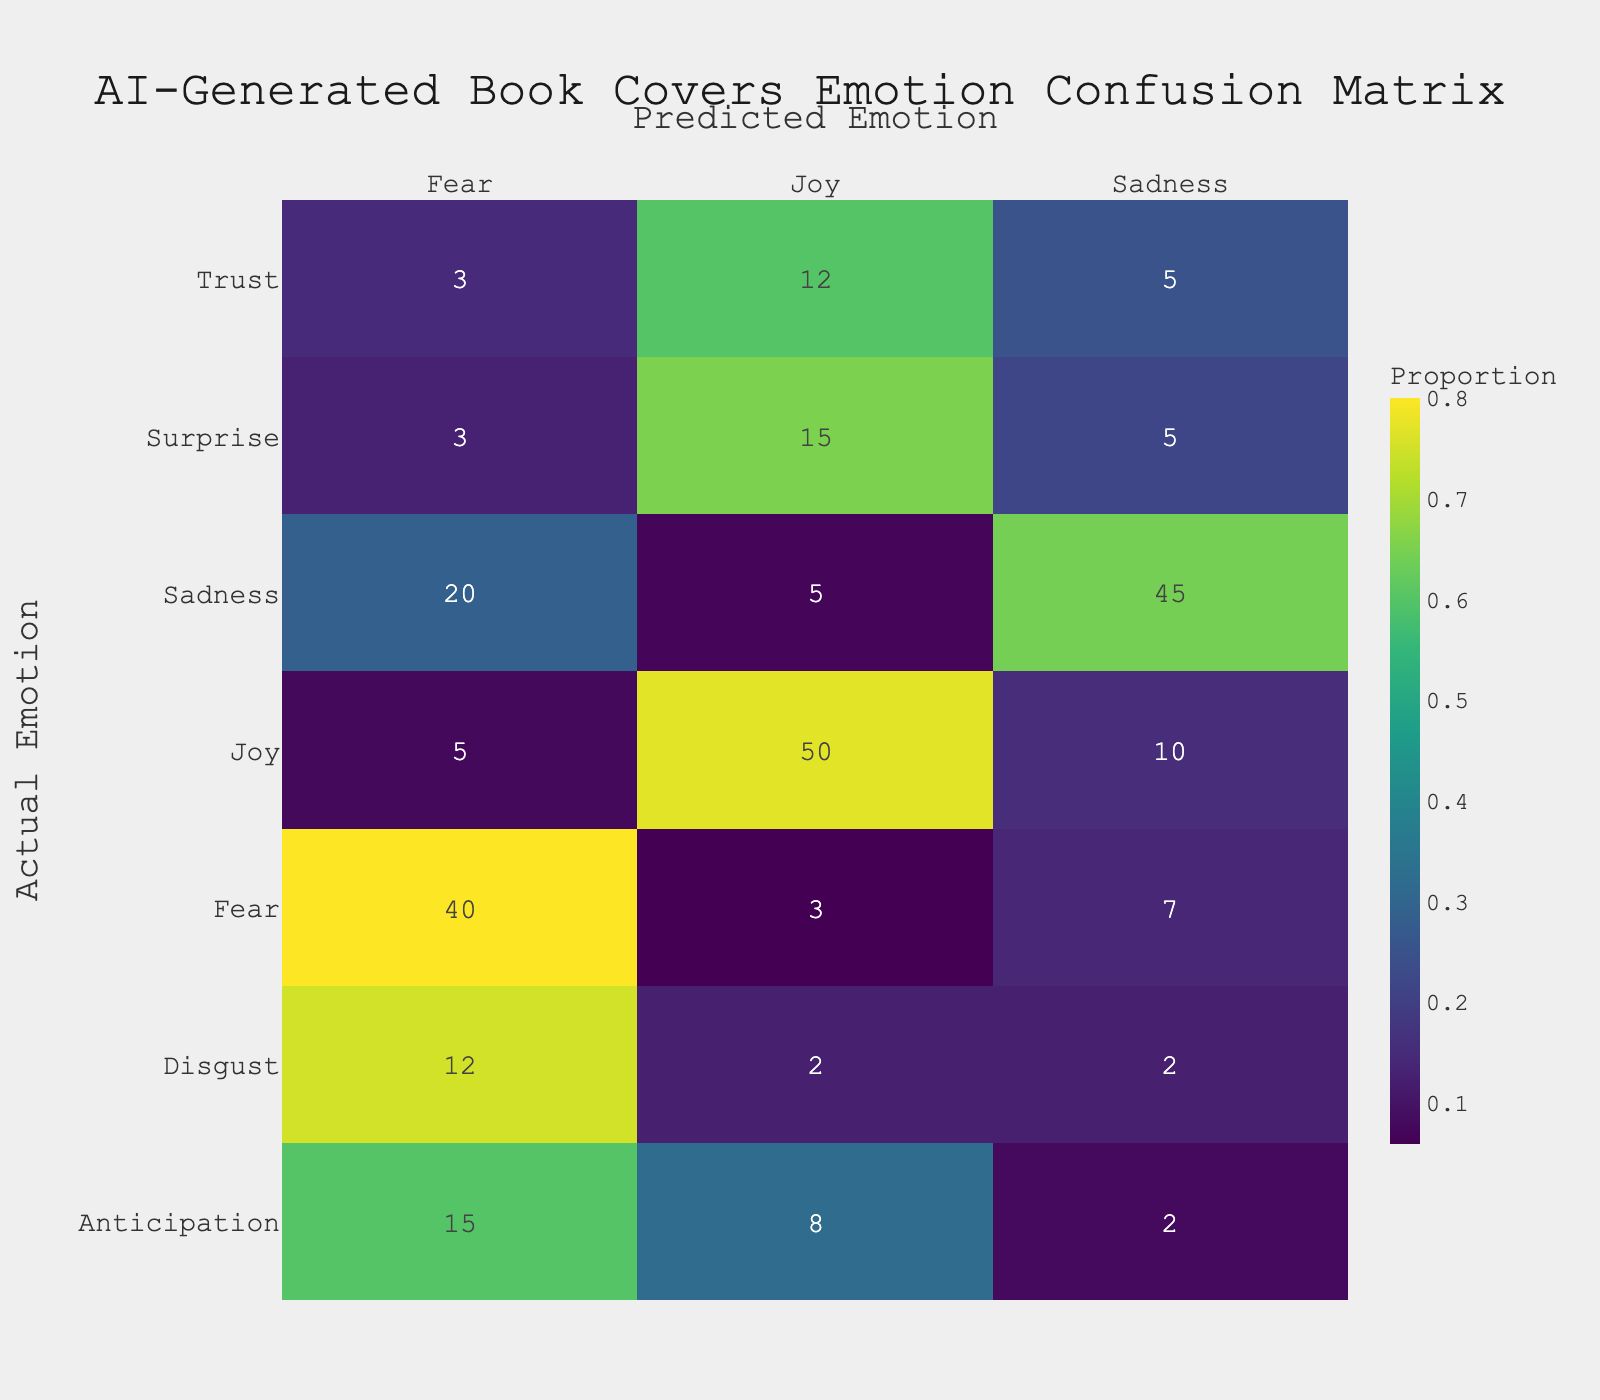What is the count of Joy predicted when the actual emotion is Joy? The table shows that when the actual emotion is Joy, the predicted emotion is also Joy with a count of 50.
Answer: 50 What is the total count of predicted emotions for the actual emotion of Sadness? To find this, we sum the counts for all predicted emotions when actual emotion is Sadness: 5 (Joy) + 45 (Sadness) + 20 (Fear) = 70.
Answer: 70 Is it true that the AI predicted more emotions as Joy than any other emotion? By examining the table, we find that the total count for Joy predicted across all actual emotions is: 50 (Joy) + 5 (Sadness) + 3 (Fear) + 8 (Anticipation) + 12 (Trust) + 2 (Disgust) + 15 (Surprise) = 95. This is greater than the total counts for other predicted emotions, confirming it is true.
Answer: Yes What is the difference in count between the predicted emotions of Fear and Sadness when the actual emotion is Surprise? The count for predicted emotion Fear when actual emotion is Surprise is 3, and for Sadness it is 5. The difference is 5 - 3 = 2.
Answer: 2 What proportion of the times did the AI predict Sadness when the actual emotion was Joy? The count for predicting Sadness when the actual emotion was Joy is 10, and the total count for Joy as the actual emotion is 50. To find the proportion, divide: 10/50 = 0.2.
Answer: 0.2 